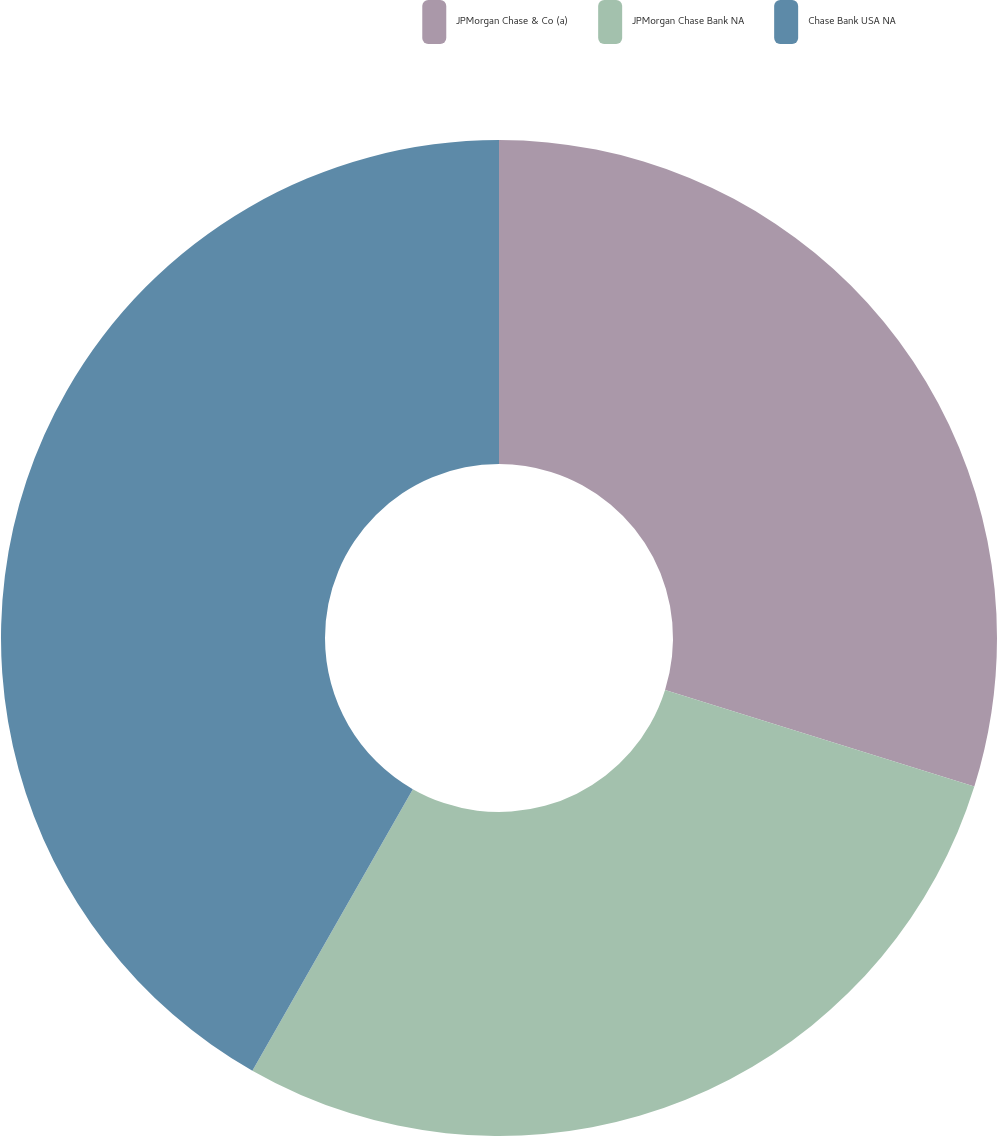Convert chart. <chart><loc_0><loc_0><loc_500><loc_500><pie_chart><fcel>JPMorgan Chase & Co (a)<fcel>JPMorgan Chase Bank NA<fcel>Chase Bank USA NA<nl><fcel>29.82%<fcel>28.42%<fcel>41.75%<nl></chart> 